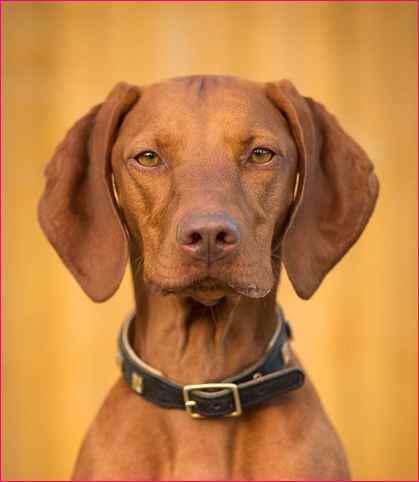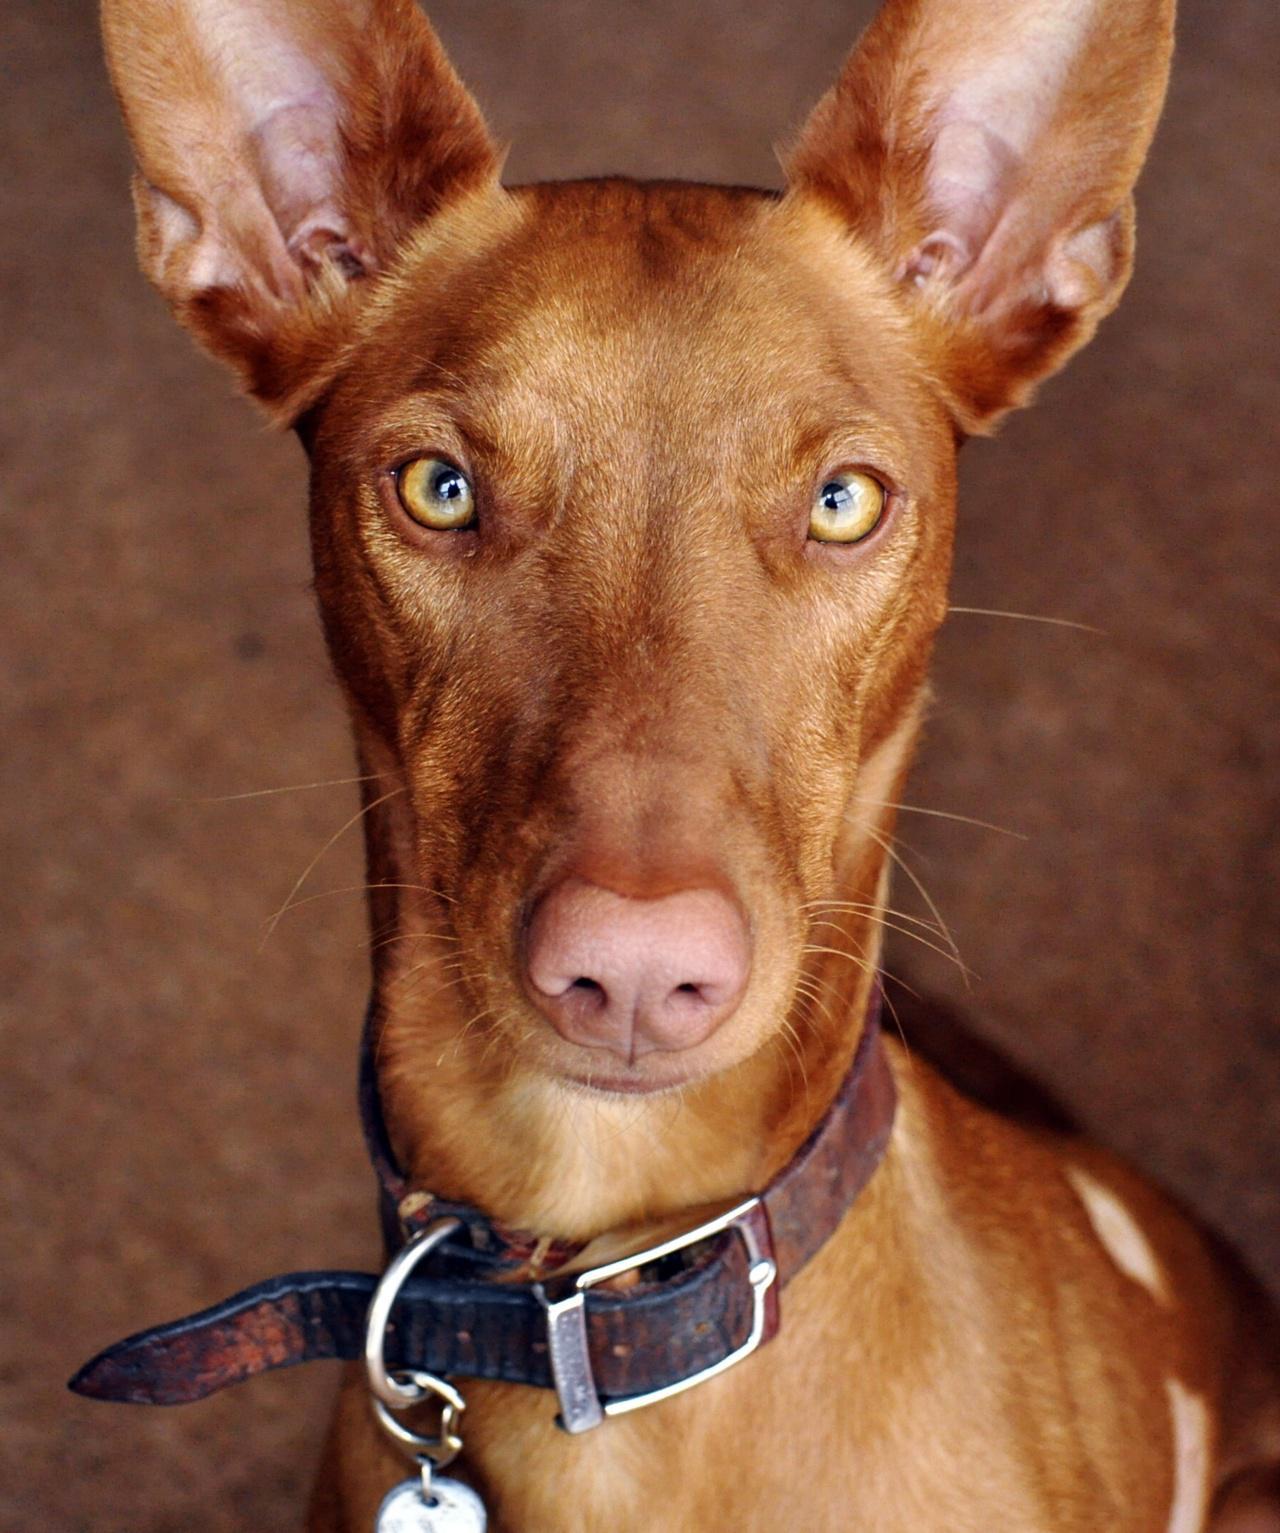The first image is the image on the left, the second image is the image on the right. Given the left and right images, does the statement "The one dog in each image is wearing a collar." hold true? Answer yes or no. Yes. The first image is the image on the left, the second image is the image on the right. Analyze the images presented: Is the assertion "Each image contains a single dog with floppy ears, and one image shows a dog outdoors in a non-reclining pose with its head and body angled rightward." valid? Answer yes or no. No. 